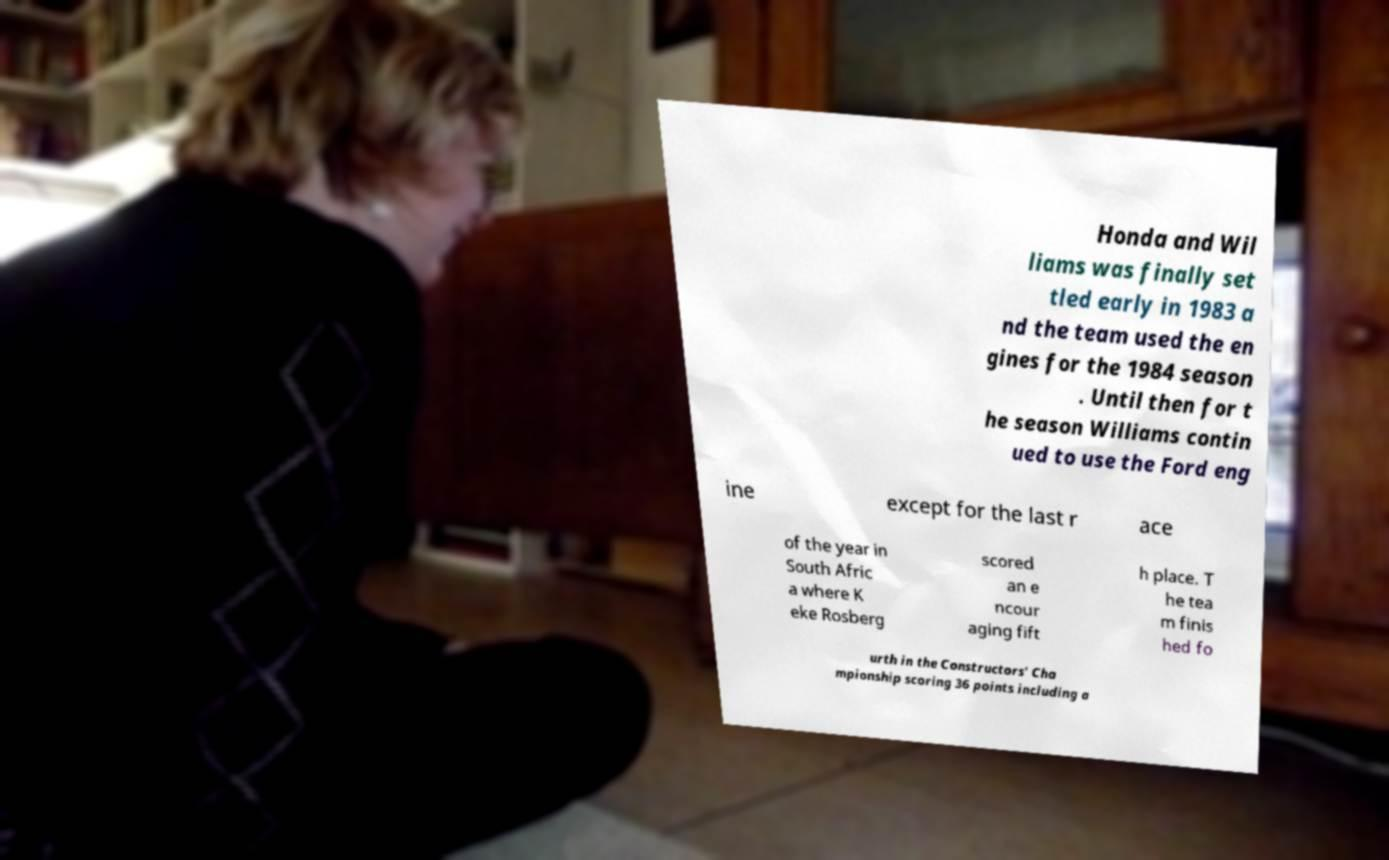Can you accurately transcribe the text from the provided image for me? Honda and Wil liams was finally set tled early in 1983 a nd the team used the en gines for the 1984 season . Until then for t he season Williams contin ued to use the Ford eng ine except for the last r ace of the year in South Afric a where K eke Rosberg scored an e ncour aging fift h place. T he tea m finis hed fo urth in the Constructors' Cha mpionship scoring 36 points including a 